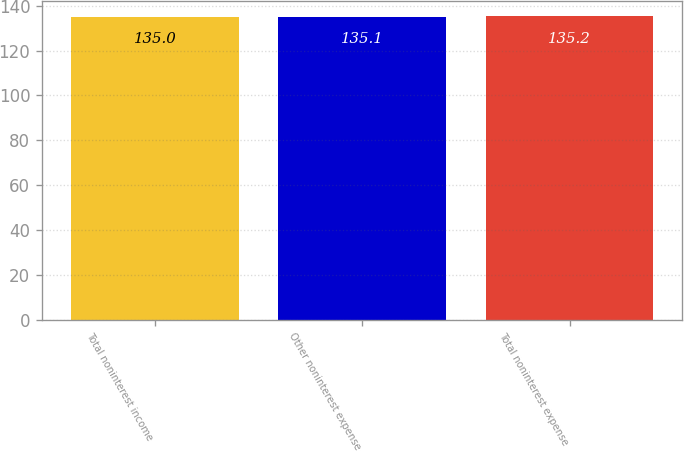Convert chart to OTSL. <chart><loc_0><loc_0><loc_500><loc_500><bar_chart><fcel>Total noninterest income<fcel>Other noninterest expense<fcel>Total noninterest expense<nl><fcel>135<fcel>135.1<fcel>135.2<nl></chart> 